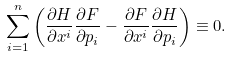Convert formula to latex. <formula><loc_0><loc_0><loc_500><loc_500>\sum _ { i = 1 } ^ { n } \left ( \frac { \partial H } { \partial x ^ { i } } \frac { \partial F } { \partial p _ { i } } - \frac { \partial F } { \partial x ^ { i } } \frac { \partial H } { \partial p _ { i } } \right ) \equiv 0 .</formula> 